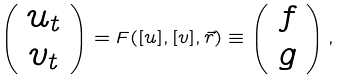Convert formula to latex. <formula><loc_0><loc_0><loc_500><loc_500>\left ( \begin{array} { c } u _ { t } \\ v _ { t } \end{array} \right ) = F ( [ u ] , [ v ] , \vec { r } ) \equiv \left ( \begin{array} { c } f \\ g \end{array} \right ) ,</formula> 